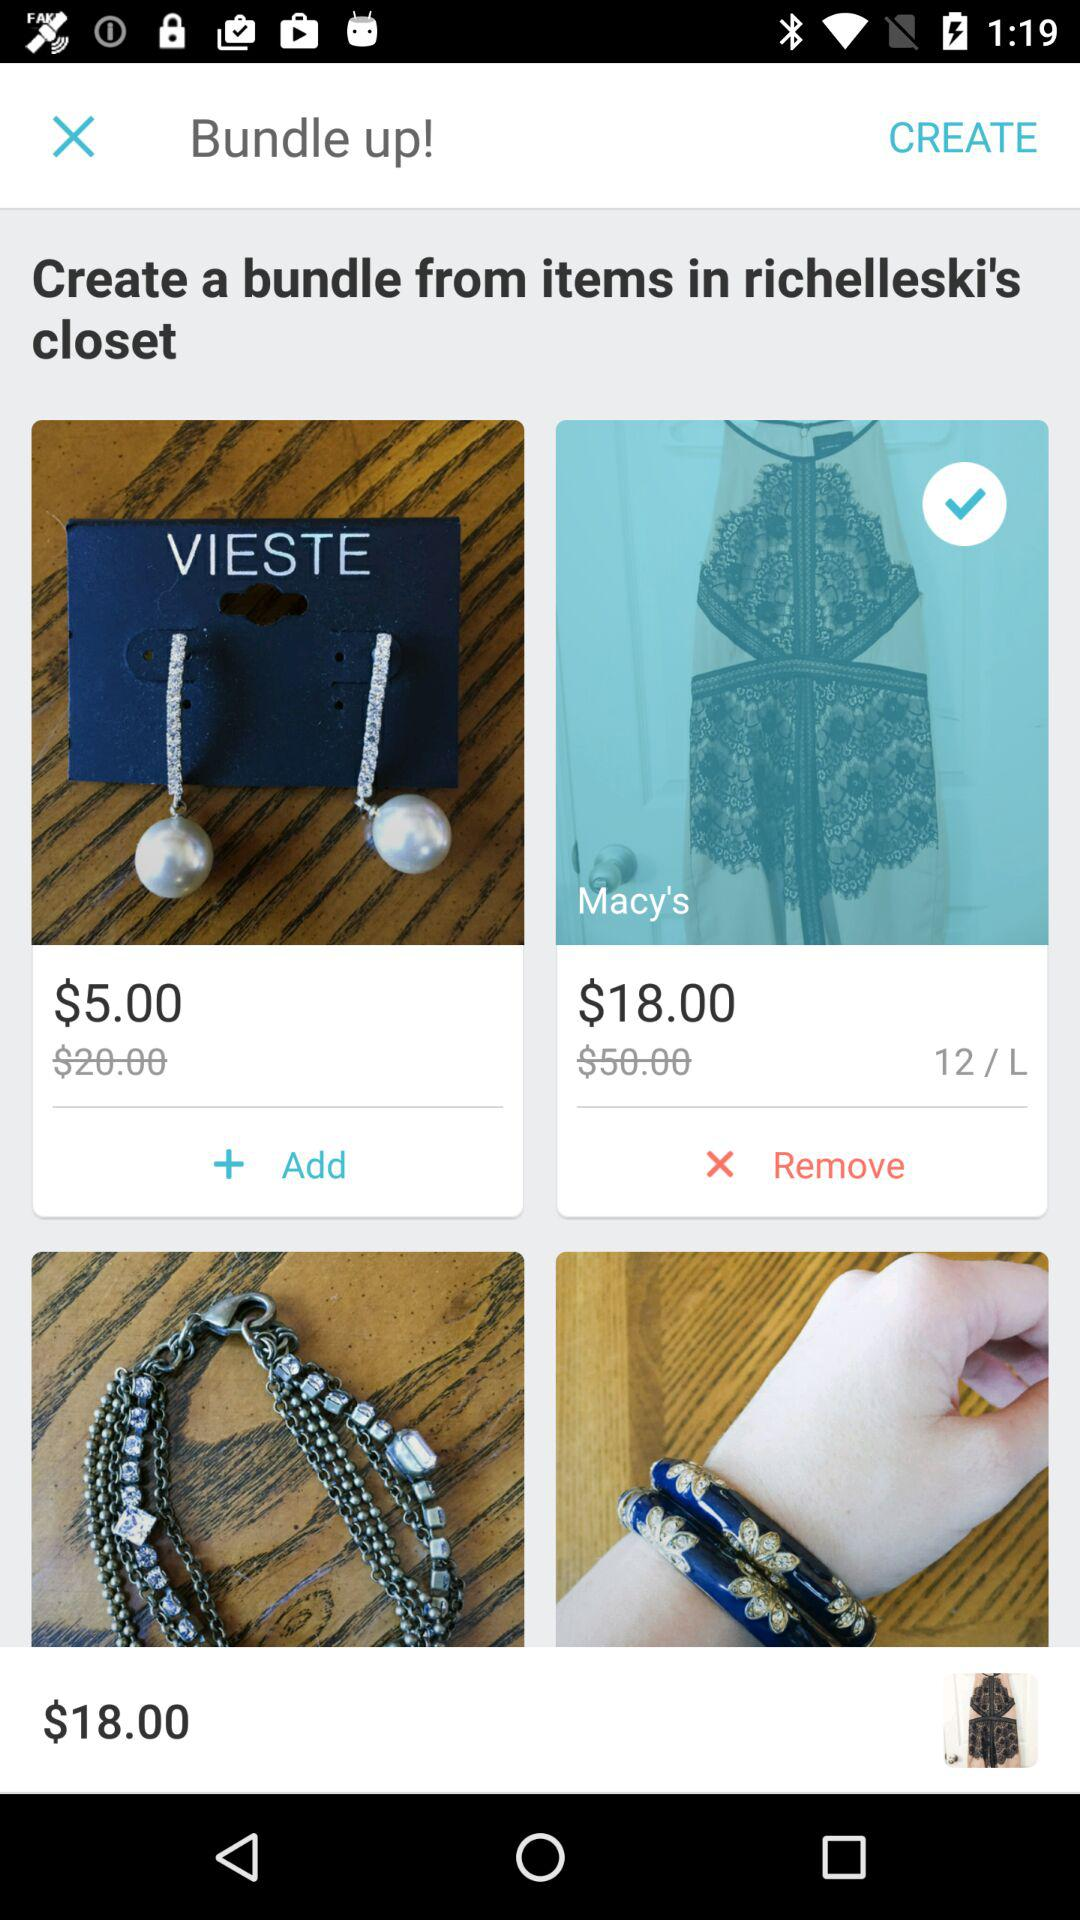What is the "Macy's" price? The "Macy's" price is $18.00. 